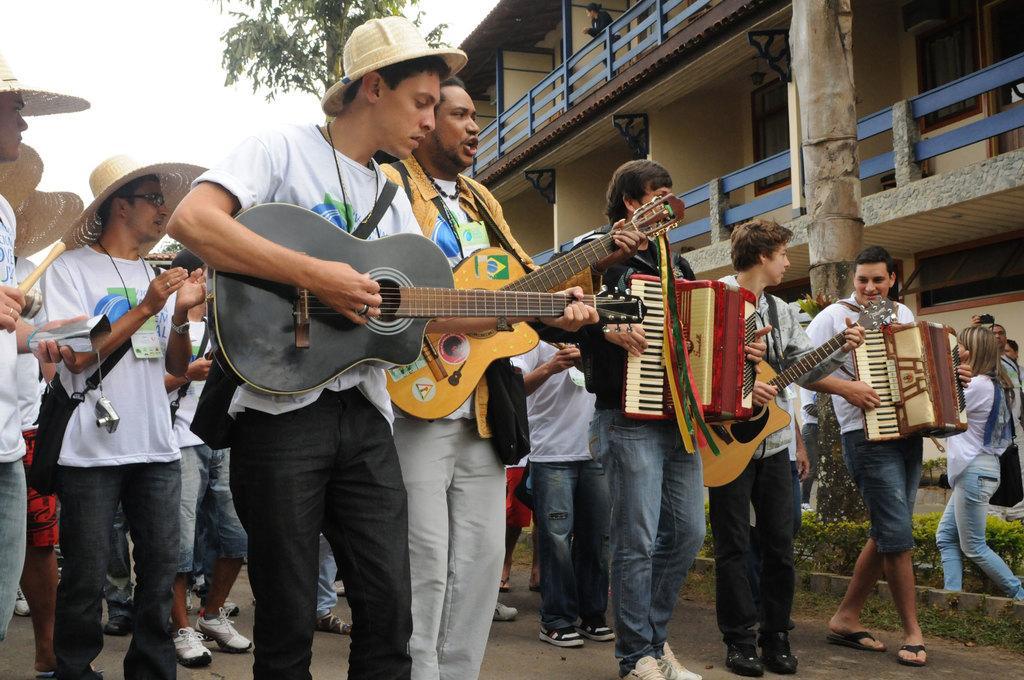Please provide a concise description of this image. In this picture we can see some people standing on the road and playing some musical instruments like guitar and harmonium. And here we can see some people who are wearing a cap. And this is the building and there is a tree. And in the background there is a sky. 